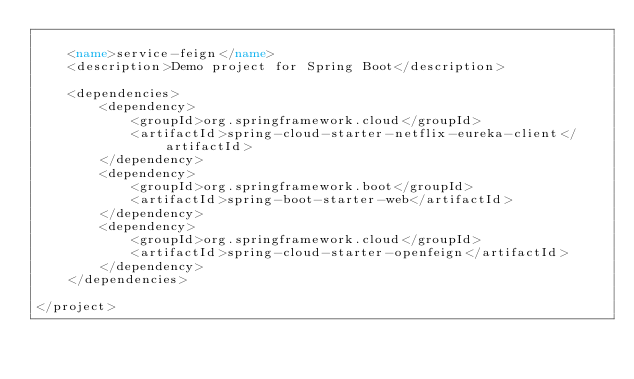<code> <loc_0><loc_0><loc_500><loc_500><_XML_>
    <name>service-feign</name>
    <description>Demo project for Spring Boot</description>

    <dependencies>
        <dependency>
            <groupId>org.springframework.cloud</groupId>
            <artifactId>spring-cloud-starter-netflix-eureka-client</artifactId>
        </dependency>
        <dependency>
            <groupId>org.springframework.boot</groupId>
            <artifactId>spring-boot-starter-web</artifactId>
        </dependency>
        <dependency>
            <groupId>org.springframework.cloud</groupId>
            <artifactId>spring-cloud-starter-openfeign</artifactId>
        </dependency>
    </dependencies>

</project>
</code> 